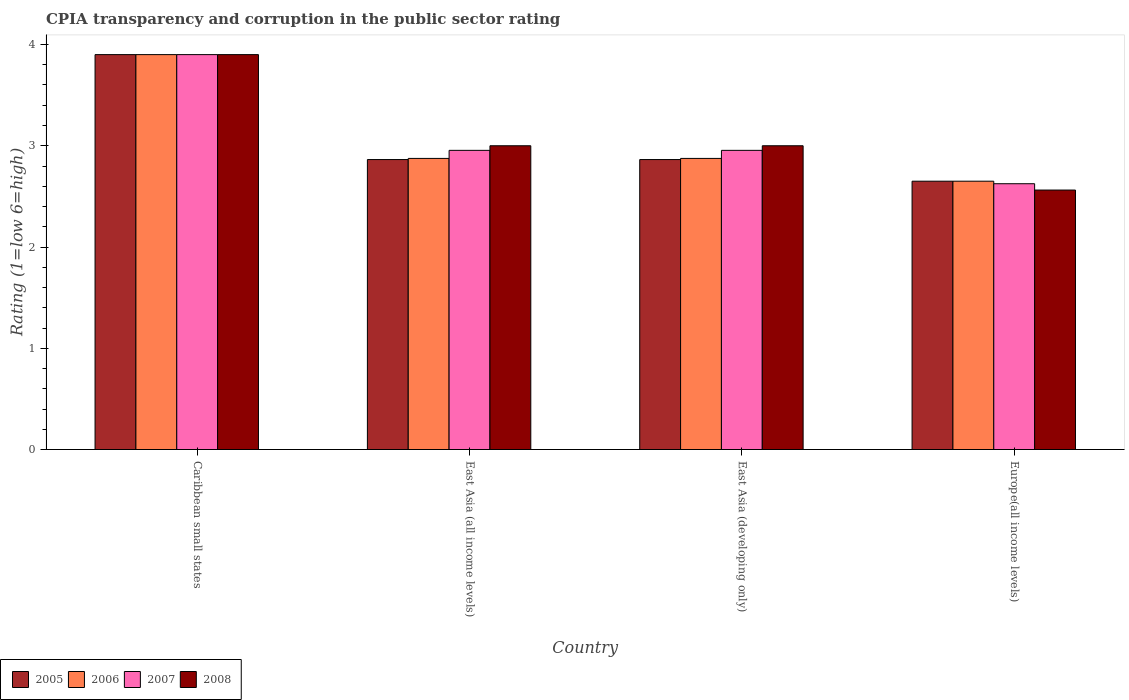How many different coloured bars are there?
Offer a very short reply. 4. Are the number of bars per tick equal to the number of legend labels?
Ensure brevity in your answer.  Yes. What is the label of the 3rd group of bars from the left?
Provide a short and direct response. East Asia (developing only). What is the CPIA rating in 2005 in Europe(all income levels)?
Make the answer very short. 2.65. Across all countries, what is the minimum CPIA rating in 2007?
Provide a short and direct response. 2.62. In which country was the CPIA rating in 2008 maximum?
Offer a terse response. Caribbean small states. In which country was the CPIA rating in 2007 minimum?
Offer a very short reply. Europe(all income levels). What is the total CPIA rating in 2006 in the graph?
Your answer should be compact. 12.3. What is the difference between the CPIA rating in 2006 in East Asia (all income levels) and that in East Asia (developing only)?
Provide a short and direct response. 0. What is the difference between the CPIA rating in 2007 in East Asia (all income levels) and the CPIA rating in 2005 in East Asia (developing only)?
Give a very brief answer. 0.09. What is the average CPIA rating in 2007 per country?
Your answer should be very brief. 3.11. What is the ratio of the CPIA rating in 2006 in East Asia (developing only) to that in Europe(all income levels)?
Your response must be concise. 1.08. Is the CPIA rating in 2006 in Caribbean small states less than that in East Asia (developing only)?
Your response must be concise. No. What is the difference between the highest and the second highest CPIA rating in 2008?
Provide a short and direct response. -0.9. What is the difference between the highest and the lowest CPIA rating in 2005?
Offer a terse response. 1.25. Is the sum of the CPIA rating in 2006 in Caribbean small states and Europe(all income levels) greater than the maximum CPIA rating in 2005 across all countries?
Offer a very short reply. Yes. Is it the case that in every country, the sum of the CPIA rating in 2006 and CPIA rating in 2008 is greater than the sum of CPIA rating in 2007 and CPIA rating in 2005?
Keep it short and to the point. No. How many bars are there?
Provide a short and direct response. 16. What is the difference between two consecutive major ticks on the Y-axis?
Give a very brief answer. 1. Does the graph contain any zero values?
Your response must be concise. No. Where does the legend appear in the graph?
Give a very brief answer. Bottom left. What is the title of the graph?
Provide a succinct answer. CPIA transparency and corruption in the public sector rating. What is the label or title of the X-axis?
Offer a terse response. Country. What is the Rating (1=low 6=high) in 2005 in Caribbean small states?
Provide a short and direct response. 3.9. What is the Rating (1=low 6=high) of 2006 in Caribbean small states?
Your response must be concise. 3.9. What is the Rating (1=low 6=high) in 2005 in East Asia (all income levels)?
Provide a succinct answer. 2.86. What is the Rating (1=low 6=high) in 2006 in East Asia (all income levels)?
Provide a succinct answer. 2.88. What is the Rating (1=low 6=high) of 2007 in East Asia (all income levels)?
Your answer should be compact. 2.95. What is the Rating (1=low 6=high) of 2005 in East Asia (developing only)?
Make the answer very short. 2.86. What is the Rating (1=low 6=high) of 2006 in East Asia (developing only)?
Your answer should be very brief. 2.88. What is the Rating (1=low 6=high) in 2007 in East Asia (developing only)?
Your answer should be very brief. 2.95. What is the Rating (1=low 6=high) of 2005 in Europe(all income levels)?
Provide a short and direct response. 2.65. What is the Rating (1=low 6=high) in 2006 in Europe(all income levels)?
Give a very brief answer. 2.65. What is the Rating (1=low 6=high) of 2007 in Europe(all income levels)?
Your response must be concise. 2.62. What is the Rating (1=low 6=high) in 2008 in Europe(all income levels)?
Ensure brevity in your answer.  2.56. Across all countries, what is the maximum Rating (1=low 6=high) of 2006?
Your response must be concise. 3.9. Across all countries, what is the minimum Rating (1=low 6=high) in 2005?
Provide a short and direct response. 2.65. Across all countries, what is the minimum Rating (1=low 6=high) in 2006?
Give a very brief answer. 2.65. Across all countries, what is the minimum Rating (1=low 6=high) of 2007?
Give a very brief answer. 2.62. Across all countries, what is the minimum Rating (1=low 6=high) of 2008?
Your answer should be compact. 2.56. What is the total Rating (1=low 6=high) of 2005 in the graph?
Make the answer very short. 12.28. What is the total Rating (1=low 6=high) in 2006 in the graph?
Ensure brevity in your answer.  12.3. What is the total Rating (1=low 6=high) in 2007 in the graph?
Your response must be concise. 12.43. What is the total Rating (1=low 6=high) in 2008 in the graph?
Keep it short and to the point. 12.46. What is the difference between the Rating (1=low 6=high) of 2005 in Caribbean small states and that in East Asia (all income levels)?
Make the answer very short. 1.04. What is the difference between the Rating (1=low 6=high) in 2006 in Caribbean small states and that in East Asia (all income levels)?
Your answer should be very brief. 1.02. What is the difference between the Rating (1=low 6=high) of 2007 in Caribbean small states and that in East Asia (all income levels)?
Give a very brief answer. 0.95. What is the difference between the Rating (1=low 6=high) of 2005 in Caribbean small states and that in East Asia (developing only)?
Your answer should be very brief. 1.04. What is the difference between the Rating (1=low 6=high) in 2006 in Caribbean small states and that in East Asia (developing only)?
Offer a terse response. 1.02. What is the difference between the Rating (1=low 6=high) in 2007 in Caribbean small states and that in East Asia (developing only)?
Provide a succinct answer. 0.95. What is the difference between the Rating (1=low 6=high) in 2008 in Caribbean small states and that in East Asia (developing only)?
Ensure brevity in your answer.  0.9. What is the difference between the Rating (1=low 6=high) in 2006 in Caribbean small states and that in Europe(all income levels)?
Provide a succinct answer. 1.25. What is the difference between the Rating (1=low 6=high) in 2007 in Caribbean small states and that in Europe(all income levels)?
Your response must be concise. 1.27. What is the difference between the Rating (1=low 6=high) in 2008 in Caribbean small states and that in Europe(all income levels)?
Provide a succinct answer. 1.34. What is the difference between the Rating (1=low 6=high) of 2005 in East Asia (all income levels) and that in East Asia (developing only)?
Provide a short and direct response. 0. What is the difference between the Rating (1=low 6=high) in 2006 in East Asia (all income levels) and that in East Asia (developing only)?
Give a very brief answer. 0. What is the difference between the Rating (1=low 6=high) of 2008 in East Asia (all income levels) and that in East Asia (developing only)?
Offer a terse response. 0. What is the difference between the Rating (1=low 6=high) of 2005 in East Asia (all income levels) and that in Europe(all income levels)?
Your answer should be compact. 0.21. What is the difference between the Rating (1=low 6=high) of 2006 in East Asia (all income levels) and that in Europe(all income levels)?
Offer a terse response. 0.23. What is the difference between the Rating (1=low 6=high) in 2007 in East Asia (all income levels) and that in Europe(all income levels)?
Offer a terse response. 0.33. What is the difference between the Rating (1=low 6=high) of 2008 in East Asia (all income levels) and that in Europe(all income levels)?
Offer a terse response. 0.44. What is the difference between the Rating (1=low 6=high) in 2005 in East Asia (developing only) and that in Europe(all income levels)?
Your response must be concise. 0.21. What is the difference between the Rating (1=low 6=high) of 2006 in East Asia (developing only) and that in Europe(all income levels)?
Give a very brief answer. 0.23. What is the difference between the Rating (1=low 6=high) in 2007 in East Asia (developing only) and that in Europe(all income levels)?
Offer a very short reply. 0.33. What is the difference between the Rating (1=low 6=high) in 2008 in East Asia (developing only) and that in Europe(all income levels)?
Ensure brevity in your answer.  0.44. What is the difference between the Rating (1=low 6=high) in 2005 in Caribbean small states and the Rating (1=low 6=high) in 2006 in East Asia (all income levels)?
Offer a terse response. 1.02. What is the difference between the Rating (1=low 6=high) in 2005 in Caribbean small states and the Rating (1=low 6=high) in 2007 in East Asia (all income levels)?
Offer a terse response. 0.95. What is the difference between the Rating (1=low 6=high) of 2005 in Caribbean small states and the Rating (1=low 6=high) of 2008 in East Asia (all income levels)?
Ensure brevity in your answer.  0.9. What is the difference between the Rating (1=low 6=high) in 2006 in Caribbean small states and the Rating (1=low 6=high) in 2007 in East Asia (all income levels)?
Your answer should be very brief. 0.95. What is the difference between the Rating (1=low 6=high) of 2005 in Caribbean small states and the Rating (1=low 6=high) of 2006 in East Asia (developing only)?
Keep it short and to the point. 1.02. What is the difference between the Rating (1=low 6=high) in 2005 in Caribbean small states and the Rating (1=low 6=high) in 2007 in East Asia (developing only)?
Offer a terse response. 0.95. What is the difference between the Rating (1=low 6=high) of 2005 in Caribbean small states and the Rating (1=low 6=high) of 2008 in East Asia (developing only)?
Make the answer very short. 0.9. What is the difference between the Rating (1=low 6=high) in 2006 in Caribbean small states and the Rating (1=low 6=high) in 2007 in East Asia (developing only)?
Provide a short and direct response. 0.95. What is the difference between the Rating (1=low 6=high) of 2007 in Caribbean small states and the Rating (1=low 6=high) of 2008 in East Asia (developing only)?
Ensure brevity in your answer.  0.9. What is the difference between the Rating (1=low 6=high) of 2005 in Caribbean small states and the Rating (1=low 6=high) of 2006 in Europe(all income levels)?
Ensure brevity in your answer.  1.25. What is the difference between the Rating (1=low 6=high) of 2005 in Caribbean small states and the Rating (1=low 6=high) of 2007 in Europe(all income levels)?
Offer a very short reply. 1.27. What is the difference between the Rating (1=low 6=high) of 2005 in Caribbean small states and the Rating (1=low 6=high) of 2008 in Europe(all income levels)?
Provide a succinct answer. 1.34. What is the difference between the Rating (1=low 6=high) of 2006 in Caribbean small states and the Rating (1=low 6=high) of 2007 in Europe(all income levels)?
Your response must be concise. 1.27. What is the difference between the Rating (1=low 6=high) of 2006 in Caribbean small states and the Rating (1=low 6=high) of 2008 in Europe(all income levels)?
Provide a short and direct response. 1.34. What is the difference between the Rating (1=low 6=high) of 2007 in Caribbean small states and the Rating (1=low 6=high) of 2008 in Europe(all income levels)?
Ensure brevity in your answer.  1.34. What is the difference between the Rating (1=low 6=high) in 2005 in East Asia (all income levels) and the Rating (1=low 6=high) in 2006 in East Asia (developing only)?
Offer a terse response. -0.01. What is the difference between the Rating (1=low 6=high) in 2005 in East Asia (all income levels) and the Rating (1=low 6=high) in 2007 in East Asia (developing only)?
Provide a short and direct response. -0.09. What is the difference between the Rating (1=low 6=high) in 2005 in East Asia (all income levels) and the Rating (1=low 6=high) in 2008 in East Asia (developing only)?
Your answer should be compact. -0.14. What is the difference between the Rating (1=low 6=high) in 2006 in East Asia (all income levels) and the Rating (1=low 6=high) in 2007 in East Asia (developing only)?
Keep it short and to the point. -0.08. What is the difference between the Rating (1=low 6=high) in 2006 in East Asia (all income levels) and the Rating (1=low 6=high) in 2008 in East Asia (developing only)?
Your response must be concise. -0.12. What is the difference between the Rating (1=low 6=high) of 2007 in East Asia (all income levels) and the Rating (1=low 6=high) of 2008 in East Asia (developing only)?
Offer a very short reply. -0.05. What is the difference between the Rating (1=low 6=high) in 2005 in East Asia (all income levels) and the Rating (1=low 6=high) in 2006 in Europe(all income levels)?
Provide a succinct answer. 0.21. What is the difference between the Rating (1=low 6=high) in 2005 in East Asia (all income levels) and the Rating (1=low 6=high) in 2007 in Europe(all income levels)?
Give a very brief answer. 0.24. What is the difference between the Rating (1=low 6=high) of 2005 in East Asia (all income levels) and the Rating (1=low 6=high) of 2008 in Europe(all income levels)?
Your answer should be very brief. 0.3. What is the difference between the Rating (1=low 6=high) of 2006 in East Asia (all income levels) and the Rating (1=low 6=high) of 2007 in Europe(all income levels)?
Your answer should be compact. 0.25. What is the difference between the Rating (1=low 6=high) in 2006 in East Asia (all income levels) and the Rating (1=low 6=high) in 2008 in Europe(all income levels)?
Keep it short and to the point. 0.31. What is the difference between the Rating (1=low 6=high) in 2007 in East Asia (all income levels) and the Rating (1=low 6=high) in 2008 in Europe(all income levels)?
Offer a very short reply. 0.39. What is the difference between the Rating (1=low 6=high) of 2005 in East Asia (developing only) and the Rating (1=low 6=high) of 2006 in Europe(all income levels)?
Provide a short and direct response. 0.21. What is the difference between the Rating (1=low 6=high) in 2005 in East Asia (developing only) and the Rating (1=low 6=high) in 2007 in Europe(all income levels)?
Make the answer very short. 0.24. What is the difference between the Rating (1=low 6=high) in 2005 in East Asia (developing only) and the Rating (1=low 6=high) in 2008 in Europe(all income levels)?
Provide a succinct answer. 0.3. What is the difference between the Rating (1=low 6=high) in 2006 in East Asia (developing only) and the Rating (1=low 6=high) in 2008 in Europe(all income levels)?
Your response must be concise. 0.31. What is the difference between the Rating (1=low 6=high) in 2007 in East Asia (developing only) and the Rating (1=low 6=high) in 2008 in Europe(all income levels)?
Provide a succinct answer. 0.39. What is the average Rating (1=low 6=high) in 2005 per country?
Offer a terse response. 3.07. What is the average Rating (1=low 6=high) of 2006 per country?
Ensure brevity in your answer.  3.08. What is the average Rating (1=low 6=high) in 2007 per country?
Your answer should be very brief. 3.11. What is the average Rating (1=low 6=high) of 2008 per country?
Your response must be concise. 3.12. What is the difference between the Rating (1=low 6=high) in 2005 and Rating (1=low 6=high) in 2006 in Caribbean small states?
Provide a succinct answer. 0. What is the difference between the Rating (1=low 6=high) in 2005 and Rating (1=low 6=high) in 2008 in Caribbean small states?
Keep it short and to the point. 0. What is the difference between the Rating (1=low 6=high) in 2006 and Rating (1=low 6=high) in 2007 in Caribbean small states?
Provide a succinct answer. 0. What is the difference between the Rating (1=low 6=high) of 2006 and Rating (1=low 6=high) of 2008 in Caribbean small states?
Provide a succinct answer. 0. What is the difference between the Rating (1=low 6=high) in 2007 and Rating (1=low 6=high) in 2008 in Caribbean small states?
Offer a terse response. 0. What is the difference between the Rating (1=low 6=high) of 2005 and Rating (1=low 6=high) of 2006 in East Asia (all income levels)?
Give a very brief answer. -0.01. What is the difference between the Rating (1=low 6=high) of 2005 and Rating (1=low 6=high) of 2007 in East Asia (all income levels)?
Ensure brevity in your answer.  -0.09. What is the difference between the Rating (1=low 6=high) of 2005 and Rating (1=low 6=high) of 2008 in East Asia (all income levels)?
Provide a short and direct response. -0.14. What is the difference between the Rating (1=low 6=high) in 2006 and Rating (1=low 6=high) in 2007 in East Asia (all income levels)?
Offer a very short reply. -0.08. What is the difference between the Rating (1=low 6=high) of 2006 and Rating (1=low 6=high) of 2008 in East Asia (all income levels)?
Provide a short and direct response. -0.12. What is the difference between the Rating (1=low 6=high) of 2007 and Rating (1=low 6=high) of 2008 in East Asia (all income levels)?
Ensure brevity in your answer.  -0.05. What is the difference between the Rating (1=low 6=high) in 2005 and Rating (1=low 6=high) in 2006 in East Asia (developing only)?
Keep it short and to the point. -0.01. What is the difference between the Rating (1=low 6=high) of 2005 and Rating (1=low 6=high) of 2007 in East Asia (developing only)?
Make the answer very short. -0.09. What is the difference between the Rating (1=low 6=high) of 2005 and Rating (1=low 6=high) of 2008 in East Asia (developing only)?
Your response must be concise. -0.14. What is the difference between the Rating (1=low 6=high) in 2006 and Rating (1=low 6=high) in 2007 in East Asia (developing only)?
Ensure brevity in your answer.  -0.08. What is the difference between the Rating (1=low 6=high) of 2006 and Rating (1=low 6=high) of 2008 in East Asia (developing only)?
Offer a very short reply. -0.12. What is the difference between the Rating (1=low 6=high) of 2007 and Rating (1=low 6=high) of 2008 in East Asia (developing only)?
Your answer should be compact. -0.05. What is the difference between the Rating (1=low 6=high) of 2005 and Rating (1=low 6=high) of 2006 in Europe(all income levels)?
Give a very brief answer. 0. What is the difference between the Rating (1=low 6=high) of 2005 and Rating (1=low 6=high) of 2007 in Europe(all income levels)?
Offer a very short reply. 0.03. What is the difference between the Rating (1=low 6=high) in 2005 and Rating (1=low 6=high) in 2008 in Europe(all income levels)?
Offer a very short reply. 0.09. What is the difference between the Rating (1=low 6=high) of 2006 and Rating (1=low 6=high) of 2007 in Europe(all income levels)?
Give a very brief answer. 0.03. What is the difference between the Rating (1=low 6=high) in 2006 and Rating (1=low 6=high) in 2008 in Europe(all income levels)?
Your response must be concise. 0.09. What is the difference between the Rating (1=low 6=high) of 2007 and Rating (1=low 6=high) of 2008 in Europe(all income levels)?
Offer a terse response. 0.06. What is the ratio of the Rating (1=low 6=high) in 2005 in Caribbean small states to that in East Asia (all income levels)?
Provide a short and direct response. 1.36. What is the ratio of the Rating (1=low 6=high) in 2006 in Caribbean small states to that in East Asia (all income levels)?
Your response must be concise. 1.36. What is the ratio of the Rating (1=low 6=high) in 2007 in Caribbean small states to that in East Asia (all income levels)?
Your answer should be compact. 1.32. What is the ratio of the Rating (1=low 6=high) in 2005 in Caribbean small states to that in East Asia (developing only)?
Your answer should be very brief. 1.36. What is the ratio of the Rating (1=low 6=high) of 2006 in Caribbean small states to that in East Asia (developing only)?
Your answer should be compact. 1.36. What is the ratio of the Rating (1=low 6=high) in 2007 in Caribbean small states to that in East Asia (developing only)?
Make the answer very short. 1.32. What is the ratio of the Rating (1=low 6=high) in 2008 in Caribbean small states to that in East Asia (developing only)?
Your answer should be compact. 1.3. What is the ratio of the Rating (1=low 6=high) of 2005 in Caribbean small states to that in Europe(all income levels)?
Your answer should be compact. 1.47. What is the ratio of the Rating (1=low 6=high) in 2006 in Caribbean small states to that in Europe(all income levels)?
Provide a succinct answer. 1.47. What is the ratio of the Rating (1=low 6=high) of 2007 in Caribbean small states to that in Europe(all income levels)?
Your answer should be very brief. 1.49. What is the ratio of the Rating (1=low 6=high) of 2008 in Caribbean small states to that in Europe(all income levels)?
Provide a short and direct response. 1.52. What is the ratio of the Rating (1=low 6=high) in 2005 in East Asia (all income levels) to that in Europe(all income levels)?
Provide a succinct answer. 1.08. What is the ratio of the Rating (1=low 6=high) in 2006 in East Asia (all income levels) to that in Europe(all income levels)?
Your answer should be very brief. 1.08. What is the ratio of the Rating (1=low 6=high) in 2007 in East Asia (all income levels) to that in Europe(all income levels)?
Give a very brief answer. 1.13. What is the ratio of the Rating (1=low 6=high) of 2008 in East Asia (all income levels) to that in Europe(all income levels)?
Keep it short and to the point. 1.17. What is the ratio of the Rating (1=low 6=high) in 2005 in East Asia (developing only) to that in Europe(all income levels)?
Ensure brevity in your answer.  1.08. What is the ratio of the Rating (1=low 6=high) of 2006 in East Asia (developing only) to that in Europe(all income levels)?
Make the answer very short. 1.08. What is the ratio of the Rating (1=low 6=high) of 2007 in East Asia (developing only) to that in Europe(all income levels)?
Ensure brevity in your answer.  1.13. What is the ratio of the Rating (1=low 6=high) in 2008 in East Asia (developing only) to that in Europe(all income levels)?
Offer a terse response. 1.17. What is the difference between the highest and the second highest Rating (1=low 6=high) in 2005?
Offer a very short reply. 1.04. What is the difference between the highest and the second highest Rating (1=low 6=high) in 2006?
Your answer should be compact. 1.02. What is the difference between the highest and the second highest Rating (1=low 6=high) of 2007?
Offer a terse response. 0.95. What is the difference between the highest and the lowest Rating (1=low 6=high) in 2005?
Provide a succinct answer. 1.25. What is the difference between the highest and the lowest Rating (1=low 6=high) in 2006?
Give a very brief answer. 1.25. What is the difference between the highest and the lowest Rating (1=low 6=high) in 2007?
Your answer should be compact. 1.27. What is the difference between the highest and the lowest Rating (1=low 6=high) in 2008?
Ensure brevity in your answer.  1.34. 